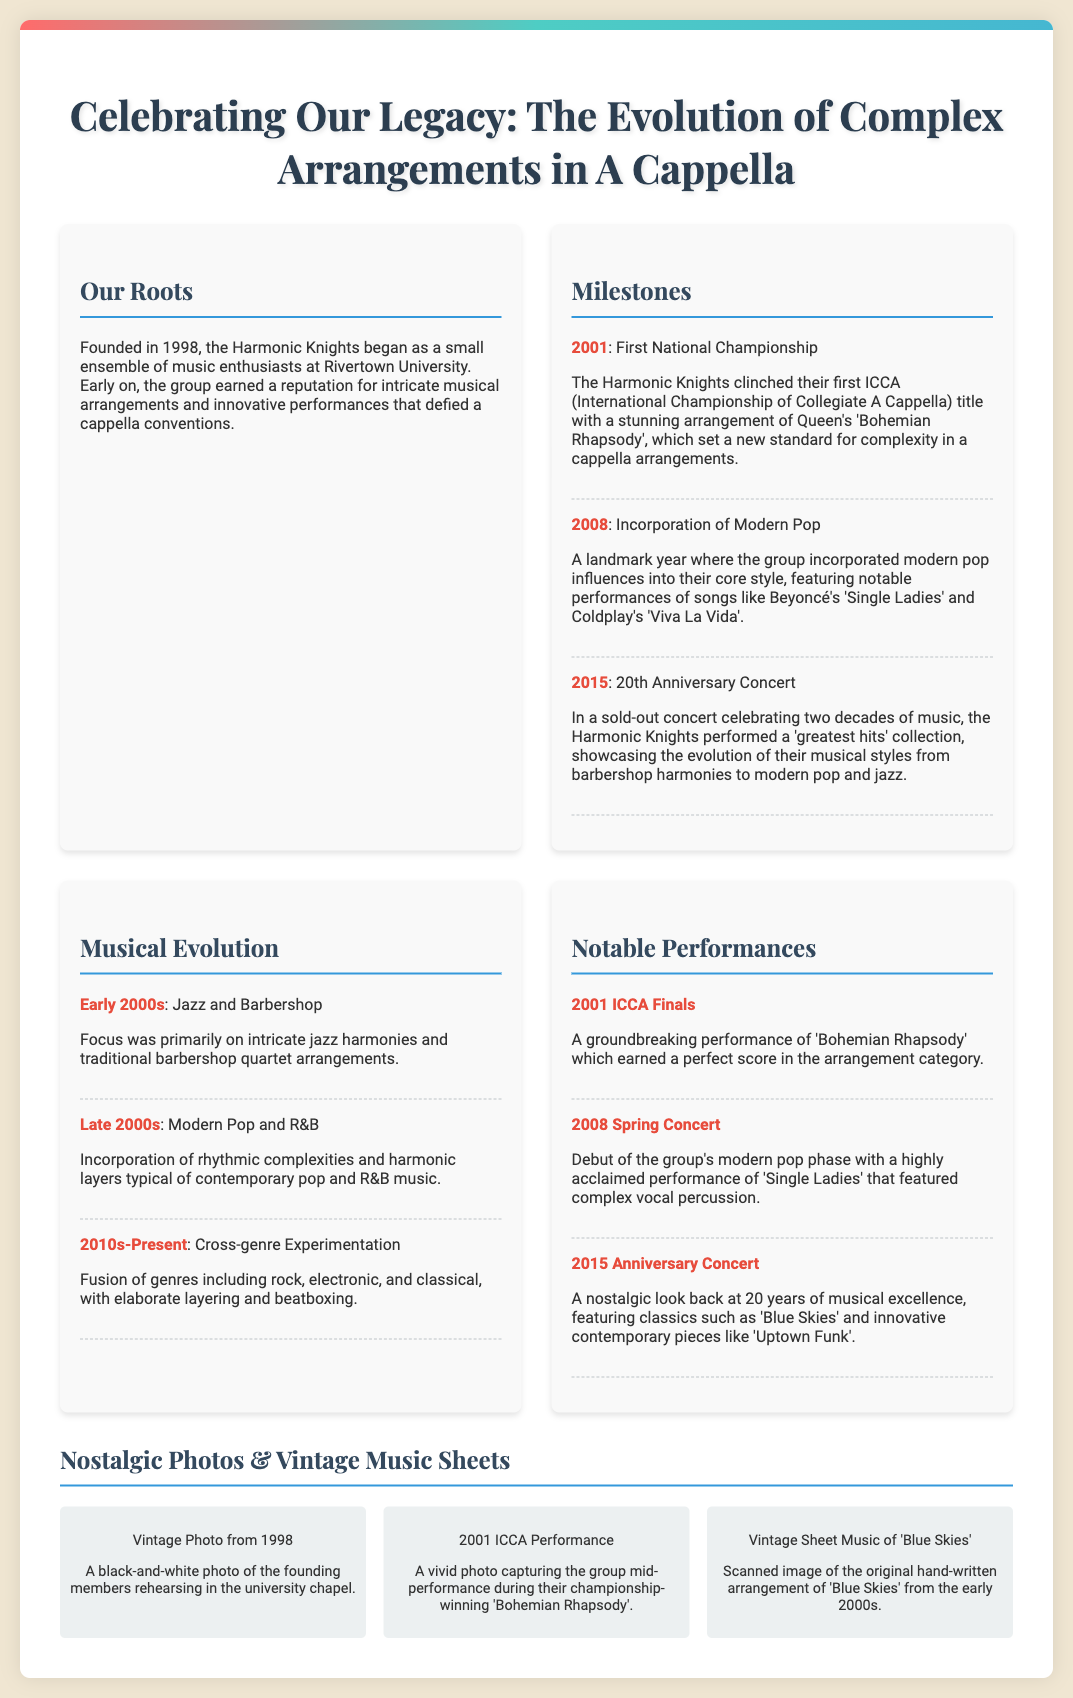What year was the group founded? The document states that the group, Harmonic Knights, was founded in 1998.
Answer: 1998 What championship did the group win in 2001? The poster mentions that they clinched their first ICCA title in 2001.
Answer: ICCA What type of music did the group focus on in the early 2000s? The document indicates that the early focus was on intricate jazz harmonies and traditional barbershop quartet arrangements.
Answer: Jazz and Barbershop Which song was performed at the 2015 Anniversary Concert? The poster highlights that classics such as 'Blue Skies' were featured at the anniversary concert in 2015.
Answer: Blue Skies What notable change happened for the group in 2008? The document states that 2008 was a landmark year for the incorporation of modern pop influences.
Answer: Incorporation of Modern Pop What is the title of the first milestone listed? According to the document, the first milestone is titled "First National Championship."
Answer: First National Championship How many years did the group celebrate in their 2015 concert? The document mentions a 20th Anniversary Concert celebrating two decades of music.
Answer: 20 What unique event is mentioned in the 2015 section of the poster? The document describes the concert as a 'greatest hits' collection showcasing evolutionary musical styles.
Answer: 'greatest hits' collection 